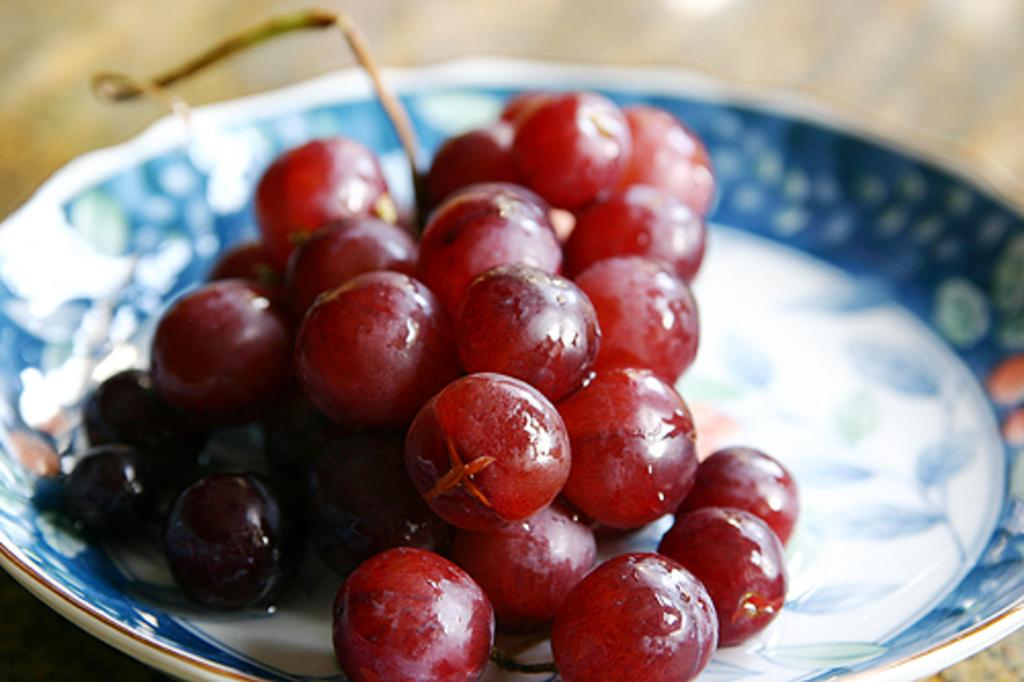What type of furniture is present in the image? There is a table in the image. What is placed on the table? There is a plate on the table. What is on the plate? The plate contains cherries. What type of structure is lifting the cherries in the image? There is no structure lifting the cherries in the image; they are simply on the plate. 